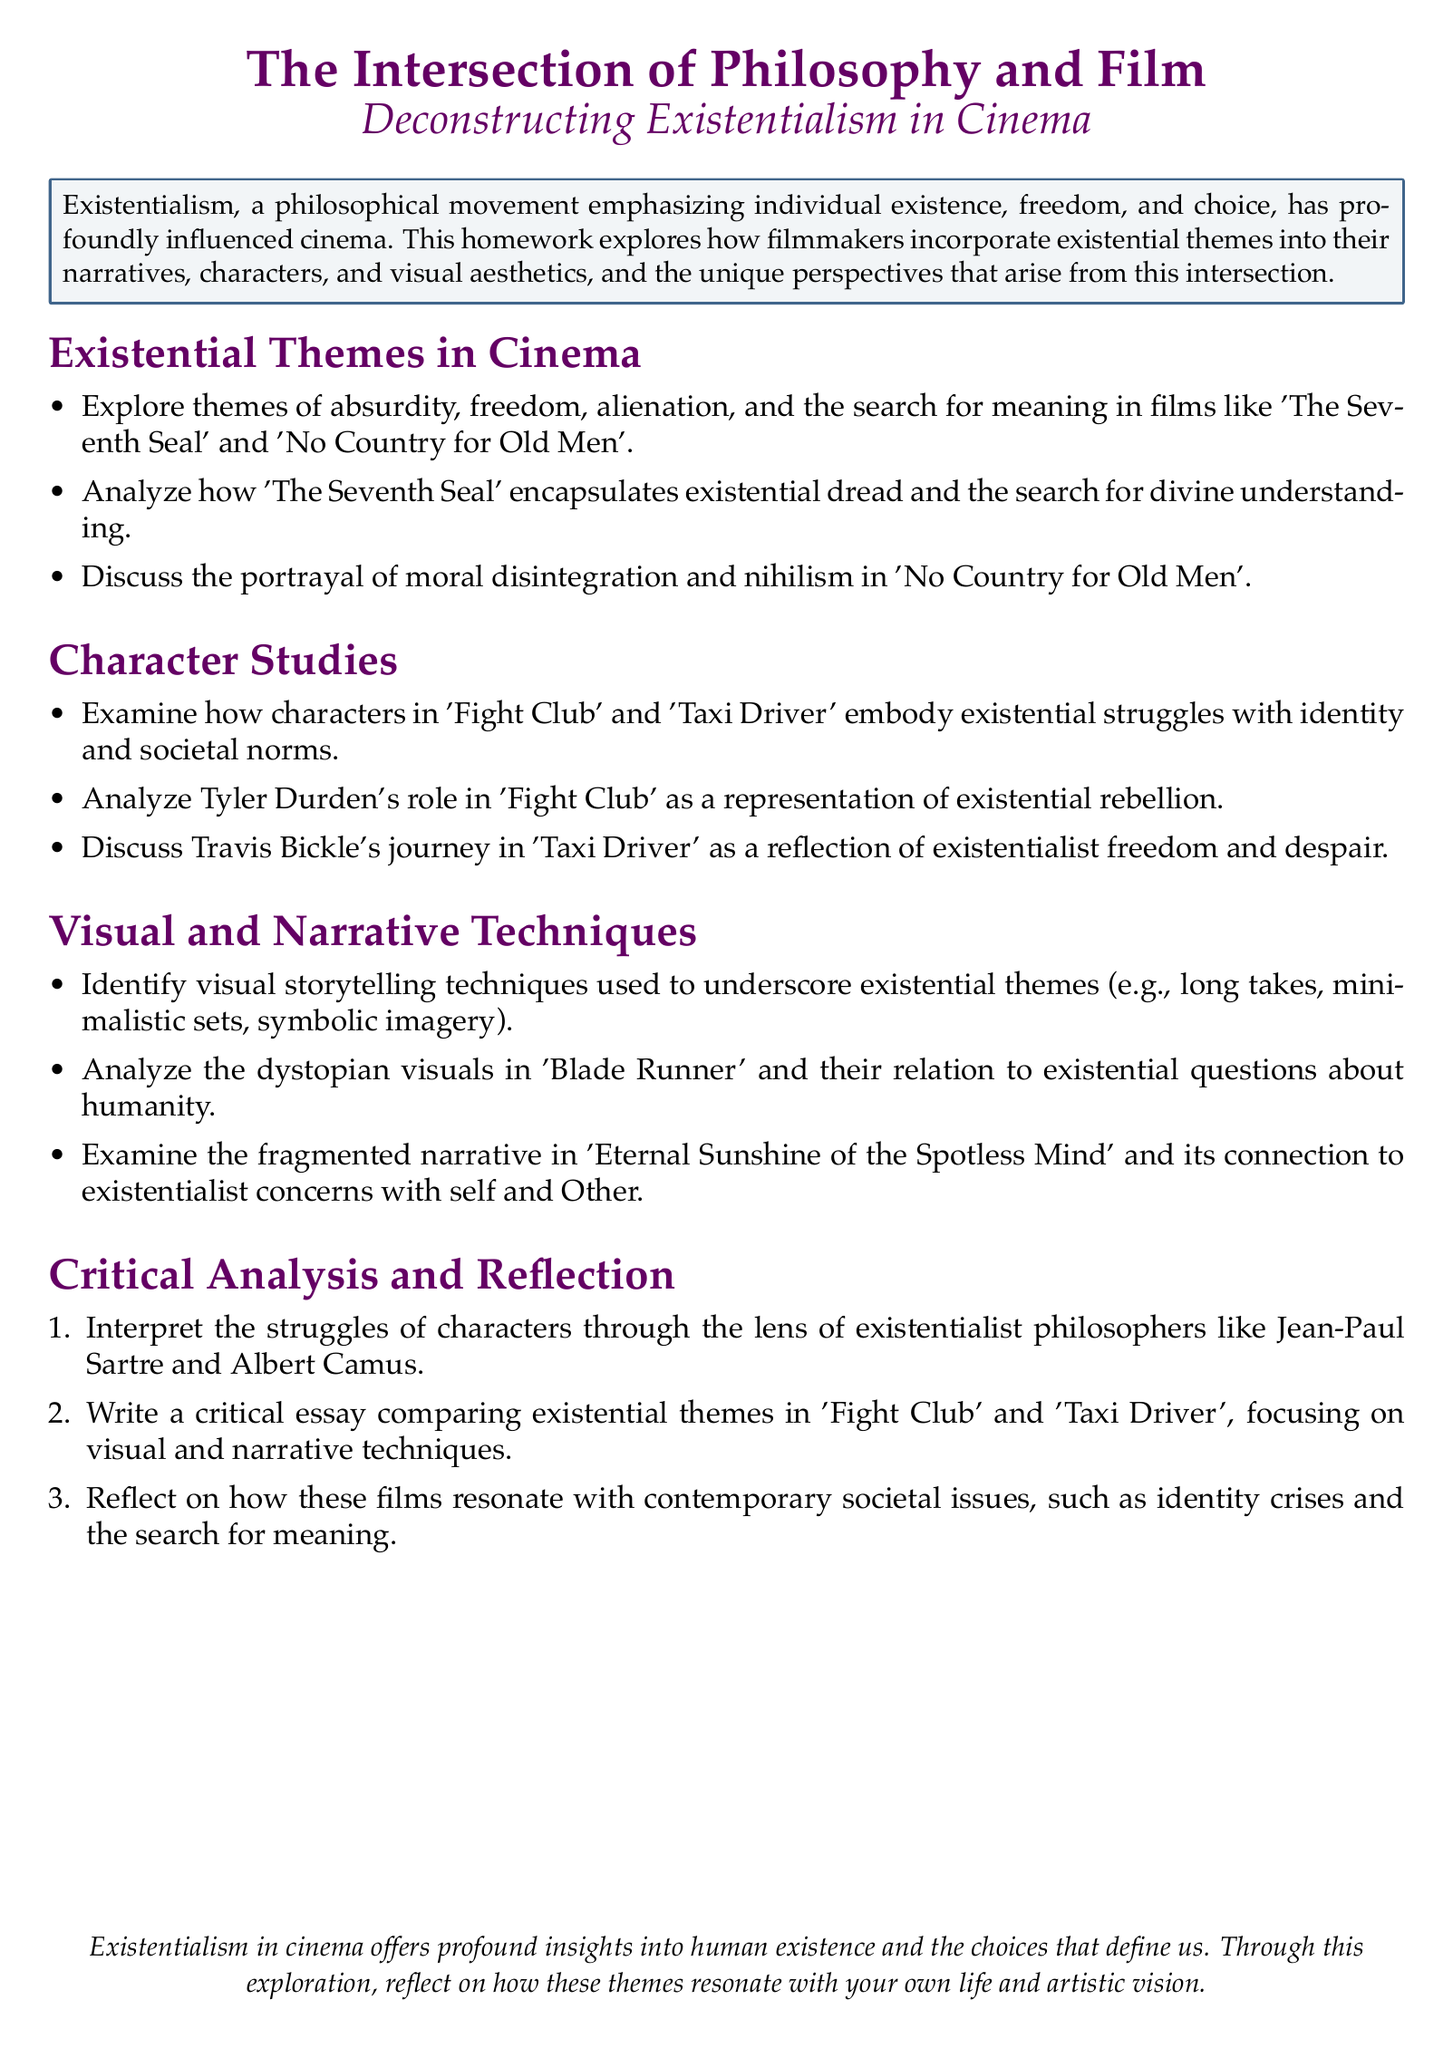What is the title of this homework? The title of the homework is prominently displayed at the beginning of the document, emphasizing its focus on philosophy and film.
Answer: The Intersection of Philosophy and Film Which two films are analyzed for existential themes of absurdity, freedom, and alienation? The document lists two specific films that encapsulate these existential themes.
Answer: The Seventh Seal and No Country for Old Men What character is analyzed in 'Fight Club' for existential rebellion? The document identifies a specific character from 'Fight Club' known for representing existential rebellion.
Answer: Tyler Durden What narrative technique is mentioned in relation to 'Eternal Sunshine of the Spotless Mind'? The document specifies a particular narrative style tied to existentialist themes in this film.
Answer: Fragmented narrative Which philosopher's thoughts are used to interpret character struggles? The document refers to a specific philosopher whose ideas inform the analysis of characters' existential struggles.
Answer: Jean-Paul Sartre 